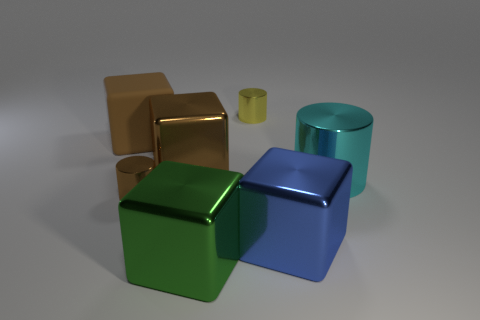What number of metal things are in front of the tiny yellow object and left of the big cyan metallic cylinder?
Your answer should be compact. 4. What is the shape of the big blue metal object to the right of the yellow shiny cylinder?
Your response must be concise. Cube. How many large balls are the same material as the blue block?
Your response must be concise. 0. There is a green thing; does it have the same shape as the large brown shiny thing that is left of the tiny yellow metallic cylinder?
Your answer should be very brief. Yes. There is a tiny metallic object that is on the right side of the brown thing in front of the big brown metallic block; are there any small objects to the left of it?
Give a very brief answer. Yes. What is the size of the brown cube that is in front of the rubber cube?
Ensure brevity in your answer.  Large. There is a green cube that is the same size as the cyan cylinder; what is it made of?
Provide a succinct answer. Metal. Does the tiny brown metal thing have the same shape as the cyan object?
Offer a very short reply. Yes. How many things are small yellow objects or blocks that are behind the tiny brown cylinder?
Keep it short and to the point. 3. There is a block on the right side of the green cube; does it have the same size as the cyan thing?
Your answer should be compact. Yes. 